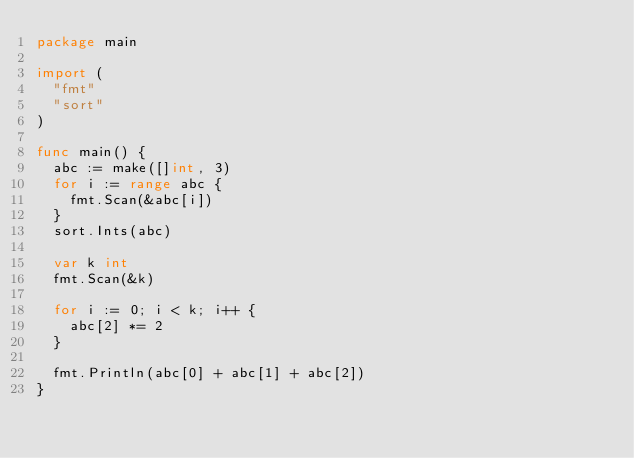<code> <loc_0><loc_0><loc_500><loc_500><_Go_>package main

import (
	"fmt"
	"sort"
)

func main() {
	abc := make([]int, 3)
	for i := range abc {
		fmt.Scan(&abc[i])
	}
	sort.Ints(abc)

	var k int
	fmt.Scan(&k)

	for i := 0; i < k; i++ {
		abc[2] *= 2
	}

	fmt.Println(abc[0] + abc[1] + abc[2])
}
</code> 